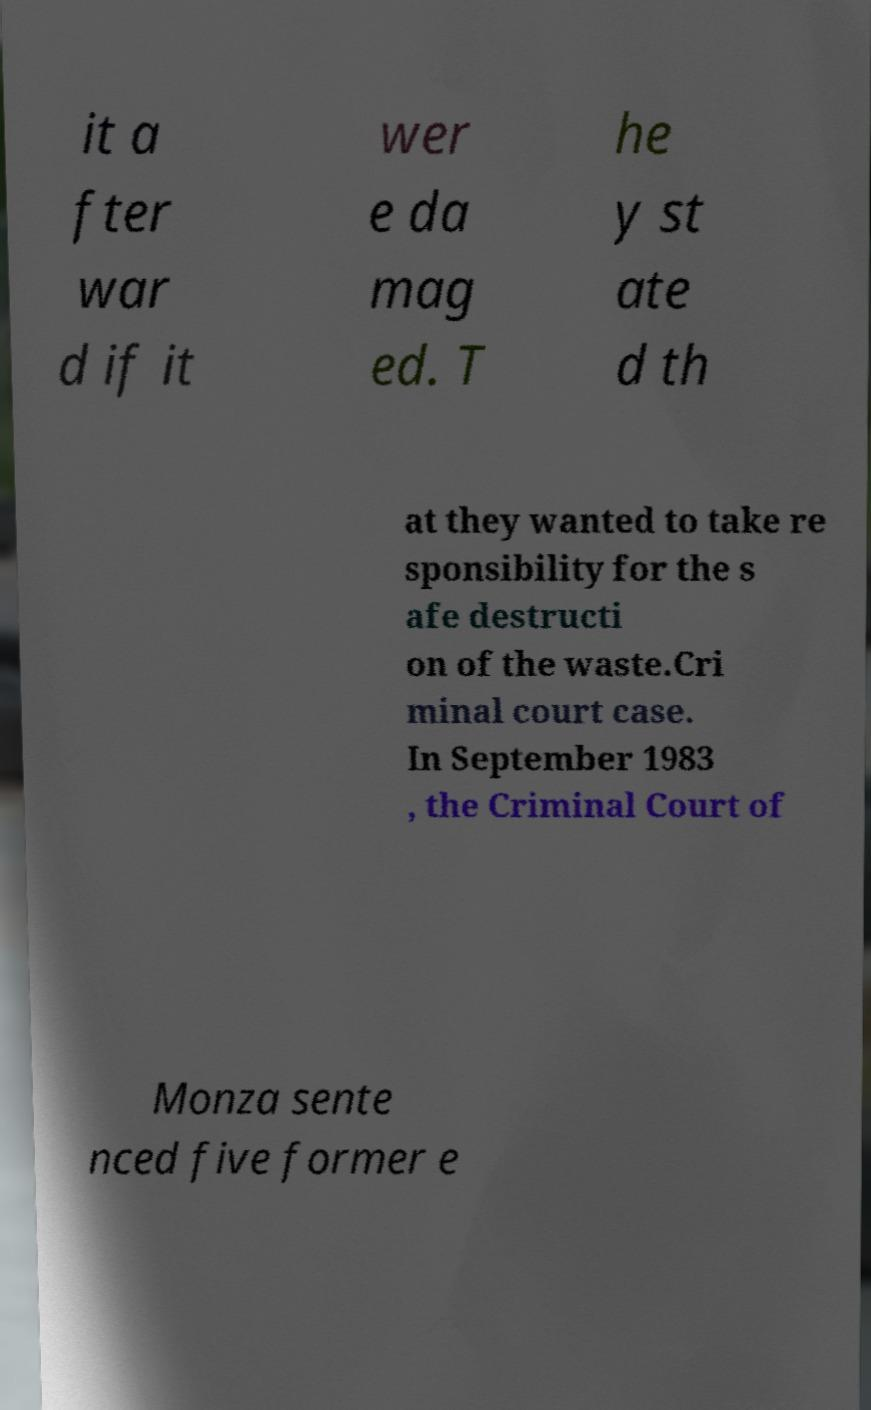There's text embedded in this image that I need extracted. Can you transcribe it verbatim? it a fter war d if it wer e da mag ed. T he y st ate d th at they wanted to take re sponsibility for the s afe destructi on of the waste.Cri minal court case. In September 1983 , the Criminal Court of Monza sente nced five former e 